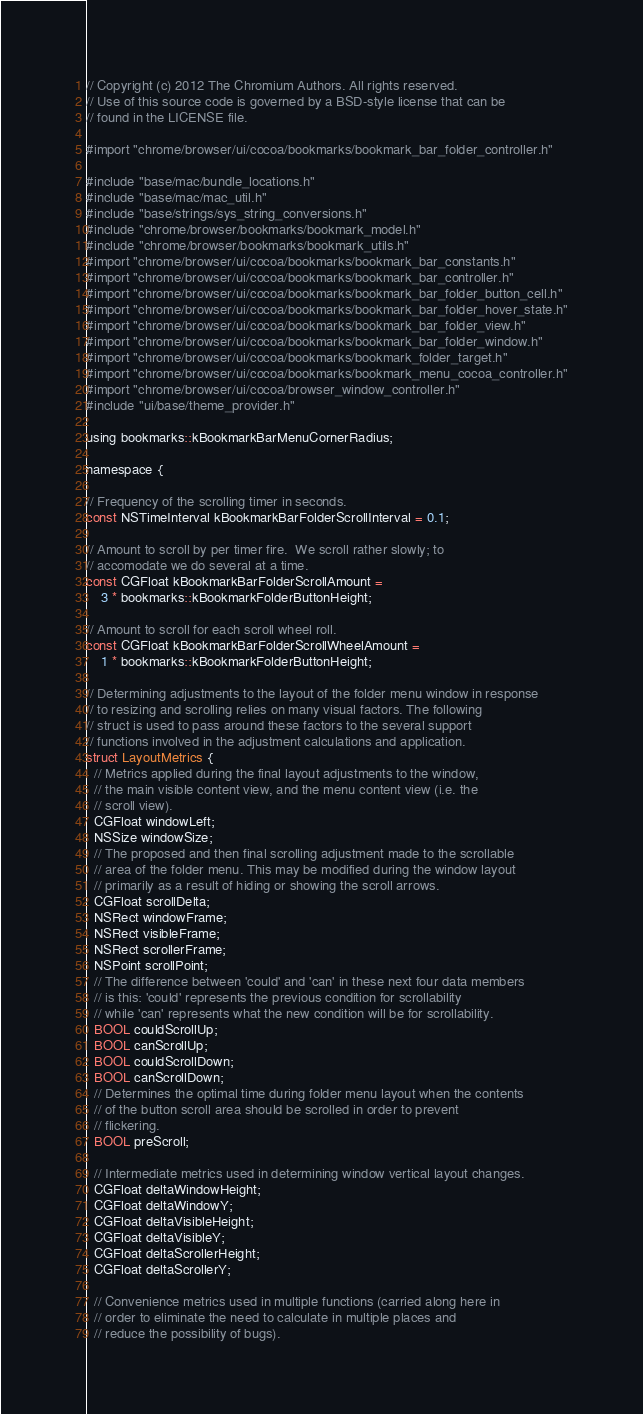<code> <loc_0><loc_0><loc_500><loc_500><_ObjectiveC_>// Copyright (c) 2012 The Chromium Authors. All rights reserved.
// Use of this source code is governed by a BSD-style license that can be
// found in the LICENSE file.

#import "chrome/browser/ui/cocoa/bookmarks/bookmark_bar_folder_controller.h"

#include "base/mac/bundle_locations.h"
#include "base/mac/mac_util.h"
#include "base/strings/sys_string_conversions.h"
#include "chrome/browser/bookmarks/bookmark_model.h"
#include "chrome/browser/bookmarks/bookmark_utils.h"
#import "chrome/browser/ui/cocoa/bookmarks/bookmark_bar_constants.h"
#import "chrome/browser/ui/cocoa/bookmarks/bookmark_bar_controller.h"
#import "chrome/browser/ui/cocoa/bookmarks/bookmark_bar_folder_button_cell.h"
#import "chrome/browser/ui/cocoa/bookmarks/bookmark_bar_folder_hover_state.h"
#import "chrome/browser/ui/cocoa/bookmarks/bookmark_bar_folder_view.h"
#import "chrome/browser/ui/cocoa/bookmarks/bookmark_bar_folder_window.h"
#import "chrome/browser/ui/cocoa/bookmarks/bookmark_folder_target.h"
#import "chrome/browser/ui/cocoa/bookmarks/bookmark_menu_cocoa_controller.h"
#import "chrome/browser/ui/cocoa/browser_window_controller.h"
#include "ui/base/theme_provider.h"

using bookmarks::kBookmarkBarMenuCornerRadius;

namespace {

// Frequency of the scrolling timer in seconds.
const NSTimeInterval kBookmarkBarFolderScrollInterval = 0.1;

// Amount to scroll by per timer fire.  We scroll rather slowly; to
// accomodate we do several at a time.
const CGFloat kBookmarkBarFolderScrollAmount =
    3 * bookmarks::kBookmarkFolderButtonHeight;

// Amount to scroll for each scroll wheel roll.
const CGFloat kBookmarkBarFolderScrollWheelAmount =
    1 * bookmarks::kBookmarkFolderButtonHeight;

// Determining adjustments to the layout of the folder menu window in response
// to resizing and scrolling relies on many visual factors. The following
// struct is used to pass around these factors to the several support
// functions involved in the adjustment calculations and application.
struct LayoutMetrics {
  // Metrics applied during the final layout adjustments to the window,
  // the main visible content view, and the menu content view (i.e. the
  // scroll view).
  CGFloat windowLeft;
  NSSize windowSize;
  // The proposed and then final scrolling adjustment made to the scrollable
  // area of the folder menu. This may be modified during the window layout
  // primarily as a result of hiding or showing the scroll arrows.
  CGFloat scrollDelta;
  NSRect windowFrame;
  NSRect visibleFrame;
  NSRect scrollerFrame;
  NSPoint scrollPoint;
  // The difference between 'could' and 'can' in these next four data members
  // is this: 'could' represents the previous condition for scrollability
  // while 'can' represents what the new condition will be for scrollability.
  BOOL couldScrollUp;
  BOOL canScrollUp;
  BOOL couldScrollDown;
  BOOL canScrollDown;
  // Determines the optimal time during folder menu layout when the contents
  // of the button scroll area should be scrolled in order to prevent
  // flickering.
  BOOL preScroll;

  // Intermediate metrics used in determining window vertical layout changes.
  CGFloat deltaWindowHeight;
  CGFloat deltaWindowY;
  CGFloat deltaVisibleHeight;
  CGFloat deltaVisibleY;
  CGFloat deltaScrollerHeight;
  CGFloat deltaScrollerY;

  // Convenience metrics used in multiple functions (carried along here in
  // order to eliminate the need to calculate in multiple places and
  // reduce the possibility of bugs).
</code> 